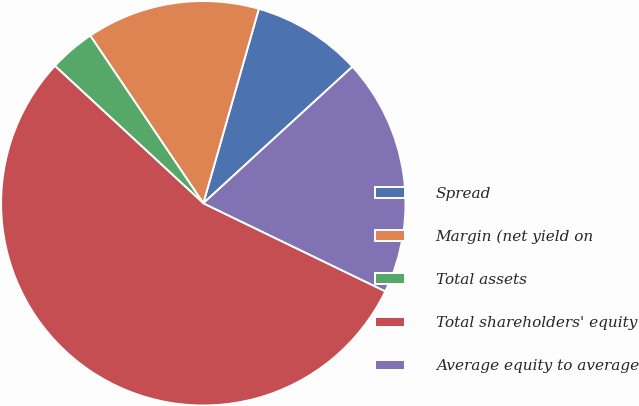Convert chart to OTSL. <chart><loc_0><loc_0><loc_500><loc_500><pie_chart><fcel>Spread<fcel>Margin (net yield on<fcel>Total assets<fcel>Total shareholders' equity<fcel>Average equity to average<nl><fcel>8.77%<fcel>13.87%<fcel>3.67%<fcel>54.71%<fcel>18.97%<nl></chart> 